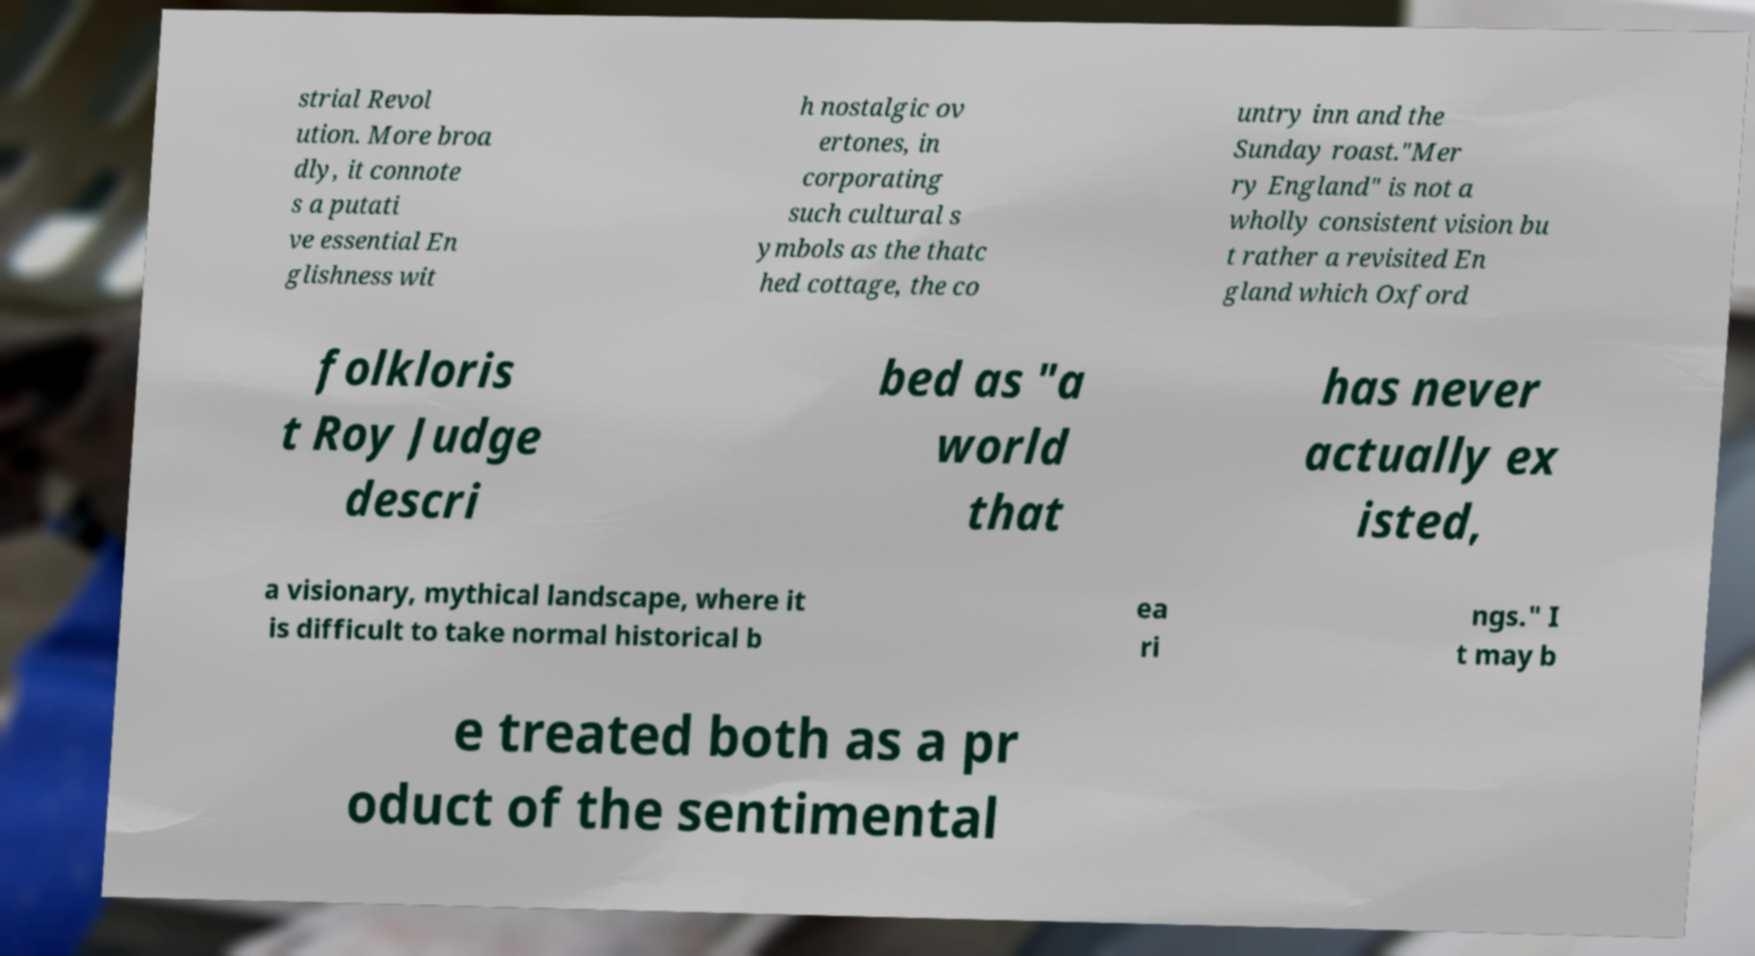Could you extract and type out the text from this image? strial Revol ution. More broa dly, it connote s a putati ve essential En glishness wit h nostalgic ov ertones, in corporating such cultural s ymbols as the thatc hed cottage, the co untry inn and the Sunday roast."Mer ry England" is not a wholly consistent vision bu t rather a revisited En gland which Oxford folkloris t Roy Judge descri bed as "a world that has never actually ex isted, a visionary, mythical landscape, where it is difficult to take normal historical b ea ri ngs." I t may b e treated both as a pr oduct of the sentimental 